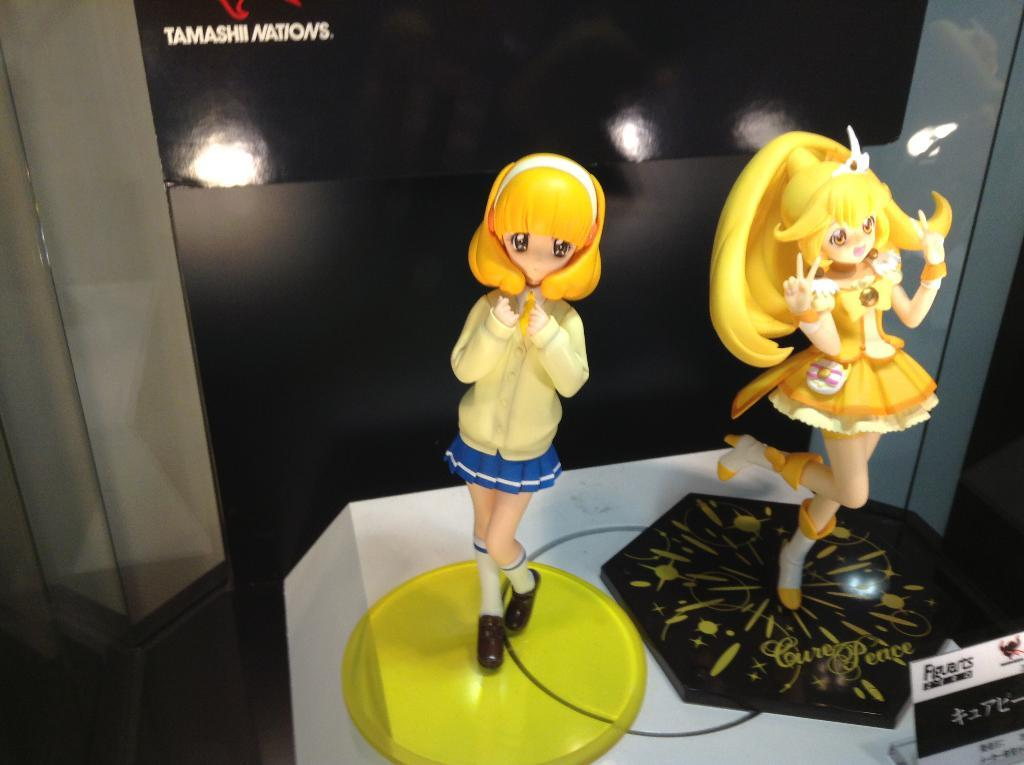What type of items can be seen in the image? There are toys and boards in the image. What are the boards used for? The boards have objects on them, and something is written on them. Can you describe the objects on the boards? Unfortunately, the facts provided do not give specific details about the objects on the boards. What direction are the bubbles moving in the image? There are no bubbles present in the image. 